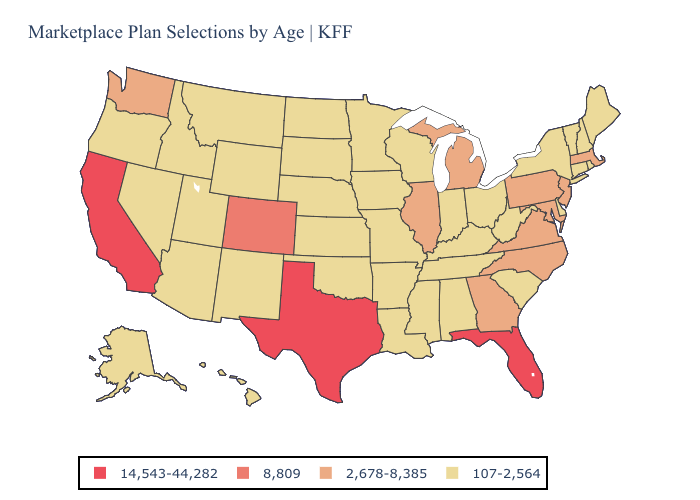Which states have the highest value in the USA?
Concise answer only. California, Florida, Texas. Which states hav the highest value in the MidWest?
Concise answer only. Illinois, Michigan. What is the value of Texas?
Be succinct. 14,543-44,282. Which states hav the highest value in the South?
Keep it brief. Florida, Texas. Does North Carolina have the highest value in the South?
Short answer required. No. What is the value of Tennessee?
Short answer required. 107-2,564. Among the states that border South Carolina , which have the lowest value?
Answer briefly. Georgia, North Carolina. What is the lowest value in the Northeast?
Short answer required. 107-2,564. Name the states that have a value in the range 107-2,564?
Short answer required. Alabama, Alaska, Arizona, Arkansas, Connecticut, Delaware, Hawaii, Idaho, Indiana, Iowa, Kansas, Kentucky, Louisiana, Maine, Minnesota, Mississippi, Missouri, Montana, Nebraska, Nevada, New Hampshire, New Mexico, New York, North Dakota, Ohio, Oklahoma, Oregon, Rhode Island, South Carolina, South Dakota, Tennessee, Utah, Vermont, West Virginia, Wisconsin, Wyoming. Does the first symbol in the legend represent the smallest category?
Quick response, please. No. What is the value of Virginia?
Give a very brief answer. 2,678-8,385. Which states hav the highest value in the South?
Keep it brief. Florida, Texas. What is the value of New Hampshire?
Keep it brief. 107-2,564. Among the states that border New Jersey , which have the highest value?
Concise answer only. Pennsylvania. 